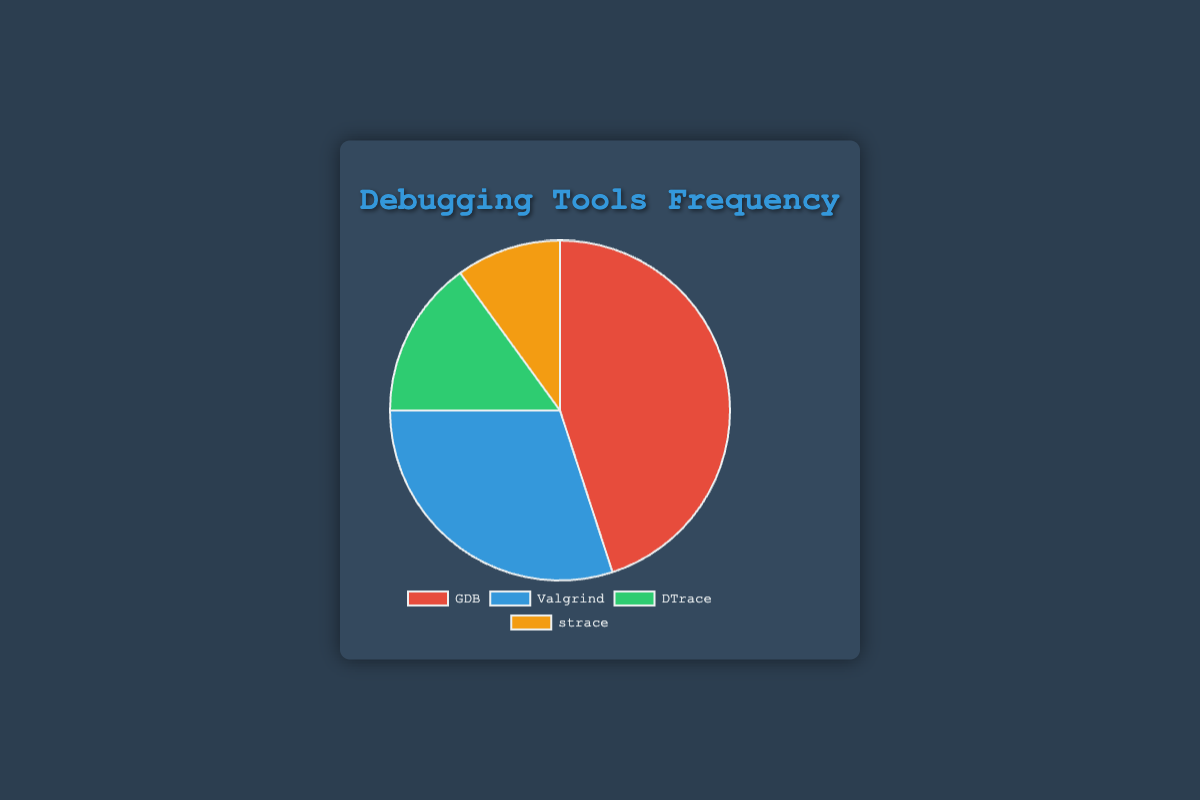What's the frequency of usage for GDB? From the chart, the slice representing GDB is labeled as having a frequency of 45, meaning it is used 45% of the time.
Answer: 45% Which debugging tool is used the least frequently? The smallest slice in the pie chart represents strace, with a frequency of 10%, indicating it is the least frequently used tool.
Answer: strace What is the combined usage frequency of Valgrind and DTrace? According to the chart, Valgrind has a frequency of 30% and DTrace has 15%. Adding these frequencies gives 30% + 15% = 45%.
Answer: 45% How much more frequently is GDB used compared to strace? GDB has a frequency of 45%, while strace has 10%. Subtracting these frequencies gives 45% - 10% = 35%.
Answer: 35% Which tool is represented by the green slice in the chart? The green slice in the chart represents DTrace, which has a frequency of 15%.
Answer: DTrace Which two tools together represent half of the total usage frequency? Valgrind is 30% and DTrace is 15%. Together, this gives us 30% + 15% = 45%. Another combination is GDB (45%) and strace (10%) summing to 45% + 10% = 55%. Thus, no combination represents exactly half, but the closest is Valgrind and DTrace at 45%.
Answer: Valgrind and DTrace Which tool is used 3 times less frequently than GDB? GDB's frequency is 45%. The tool that is used 3 times less frequently would be 45% / 3 = 15%. From the chart, DTrace has a frequency of 15%.
Answer: DTrace 